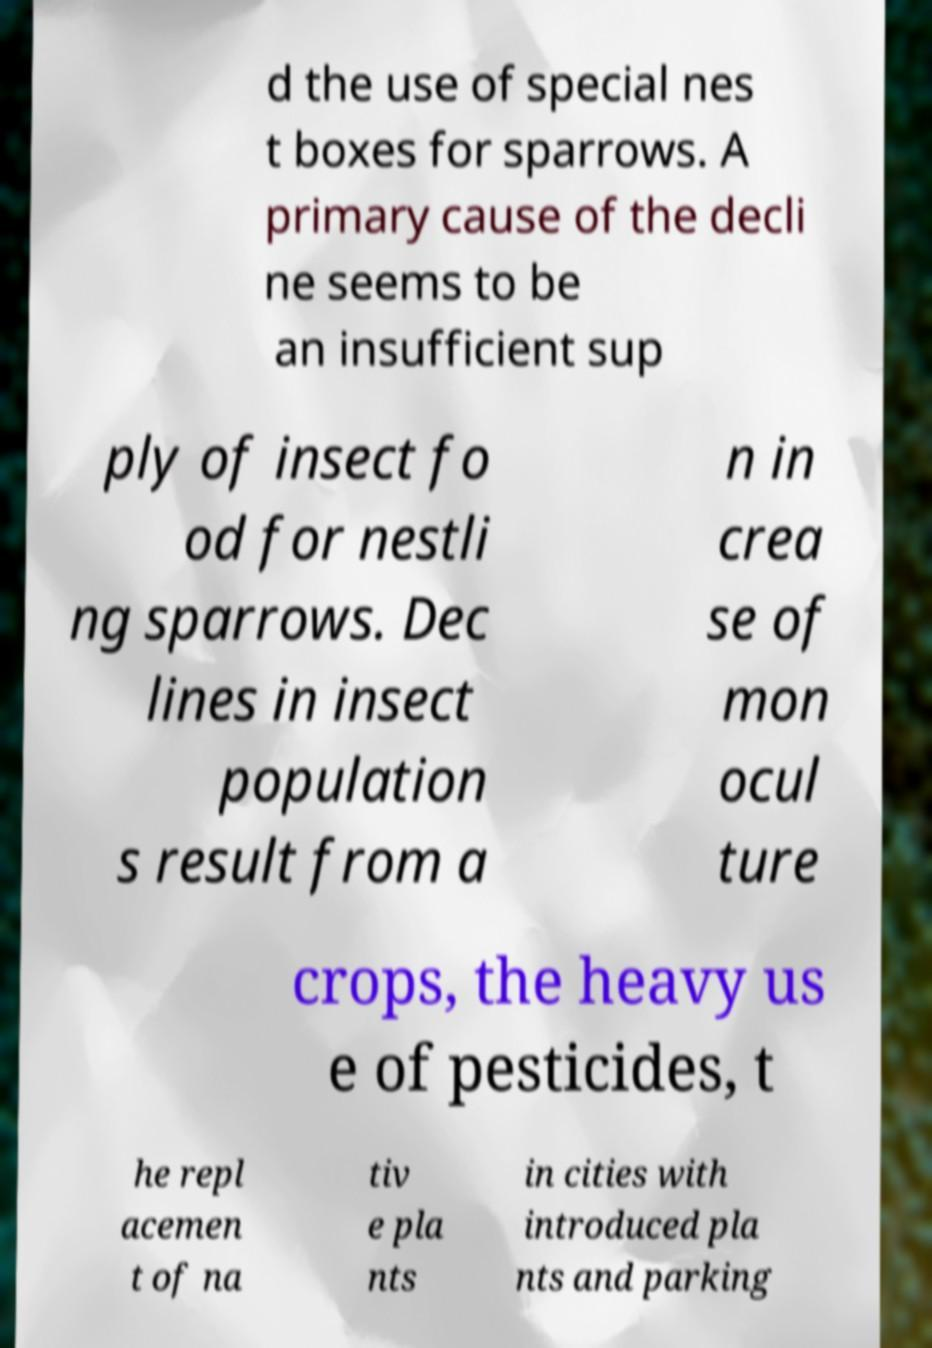Please read and relay the text visible in this image. What does it say? d the use of special nes t boxes for sparrows. A primary cause of the decli ne seems to be an insufficient sup ply of insect fo od for nestli ng sparrows. Dec lines in insect population s result from a n in crea se of mon ocul ture crops, the heavy us e of pesticides, t he repl acemen t of na tiv e pla nts in cities with introduced pla nts and parking 